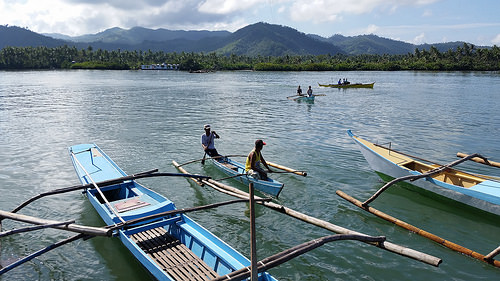<image>
Can you confirm if the boat is on the water? Yes. Looking at the image, I can see the boat is positioned on top of the water, with the water providing support. 